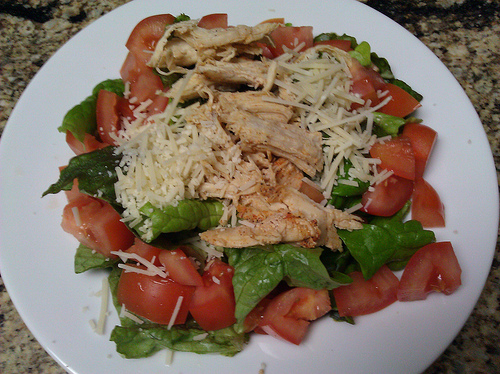<image>
Can you confirm if the cheese is on the lettuce? Yes. Looking at the image, I can see the cheese is positioned on top of the lettuce, with the lettuce providing support. Where is the tomatoe in relation to the plate? Is it on the plate? Yes. Looking at the image, I can see the tomatoe is positioned on top of the plate, with the plate providing support. 